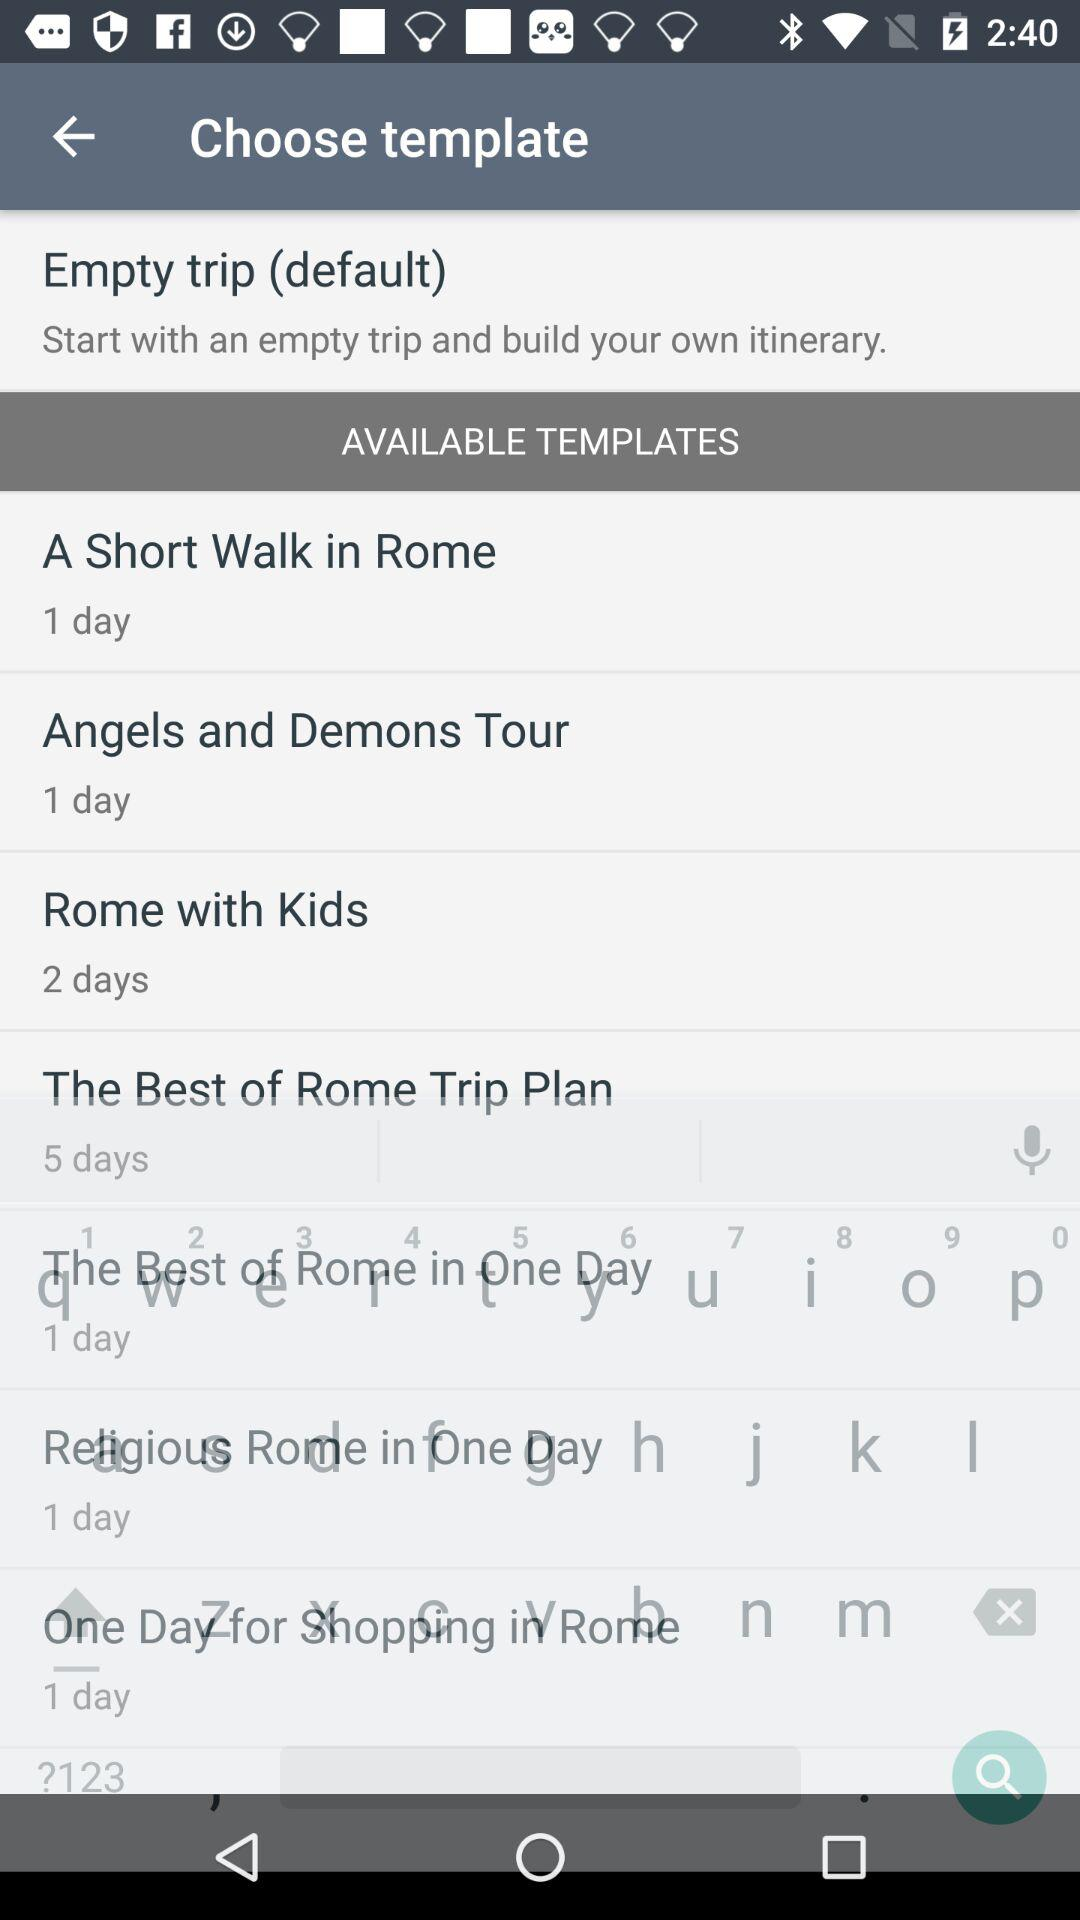Which template is selected?
When the provided information is insufficient, respond with <no answer>. <no answer> 